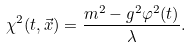<formula> <loc_0><loc_0><loc_500><loc_500>\chi ^ { 2 } ( t , \vec { x } ) = \frac { m ^ { 2 } - g ^ { 2 } \varphi ^ { 2 } ( t ) } { \lambda } .</formula> 